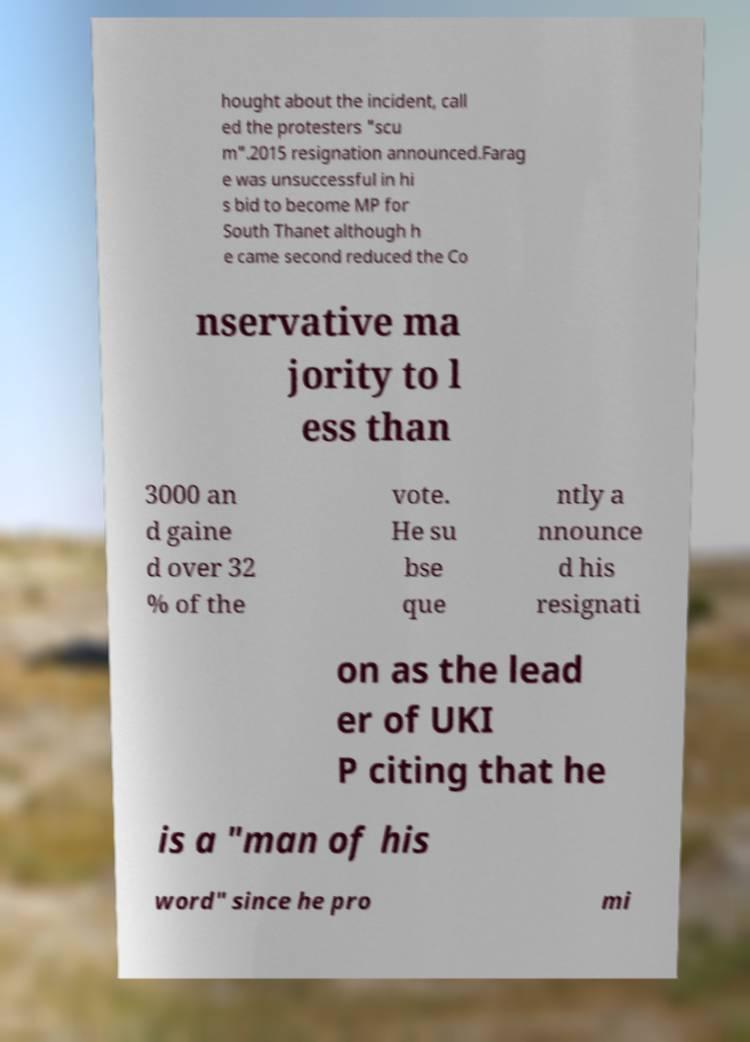Can you read and provide the text displayed in the image?This photo seems to have some interesting text. Can you extract and type it out for me? hought about the incident, call ed the protesters "scu m".2015 resignation announced.Farag e was unsuccessful in hi s bid to become MP for South Thanet although h e came second reduced the Co nservative ma jority to l ess than 3000 an d gaine d over 32 % of the vote. He su bse que ntly a nnounce d his resignati on as the lead er of UKI P citing that he is a "man of his word" since he pro mi 